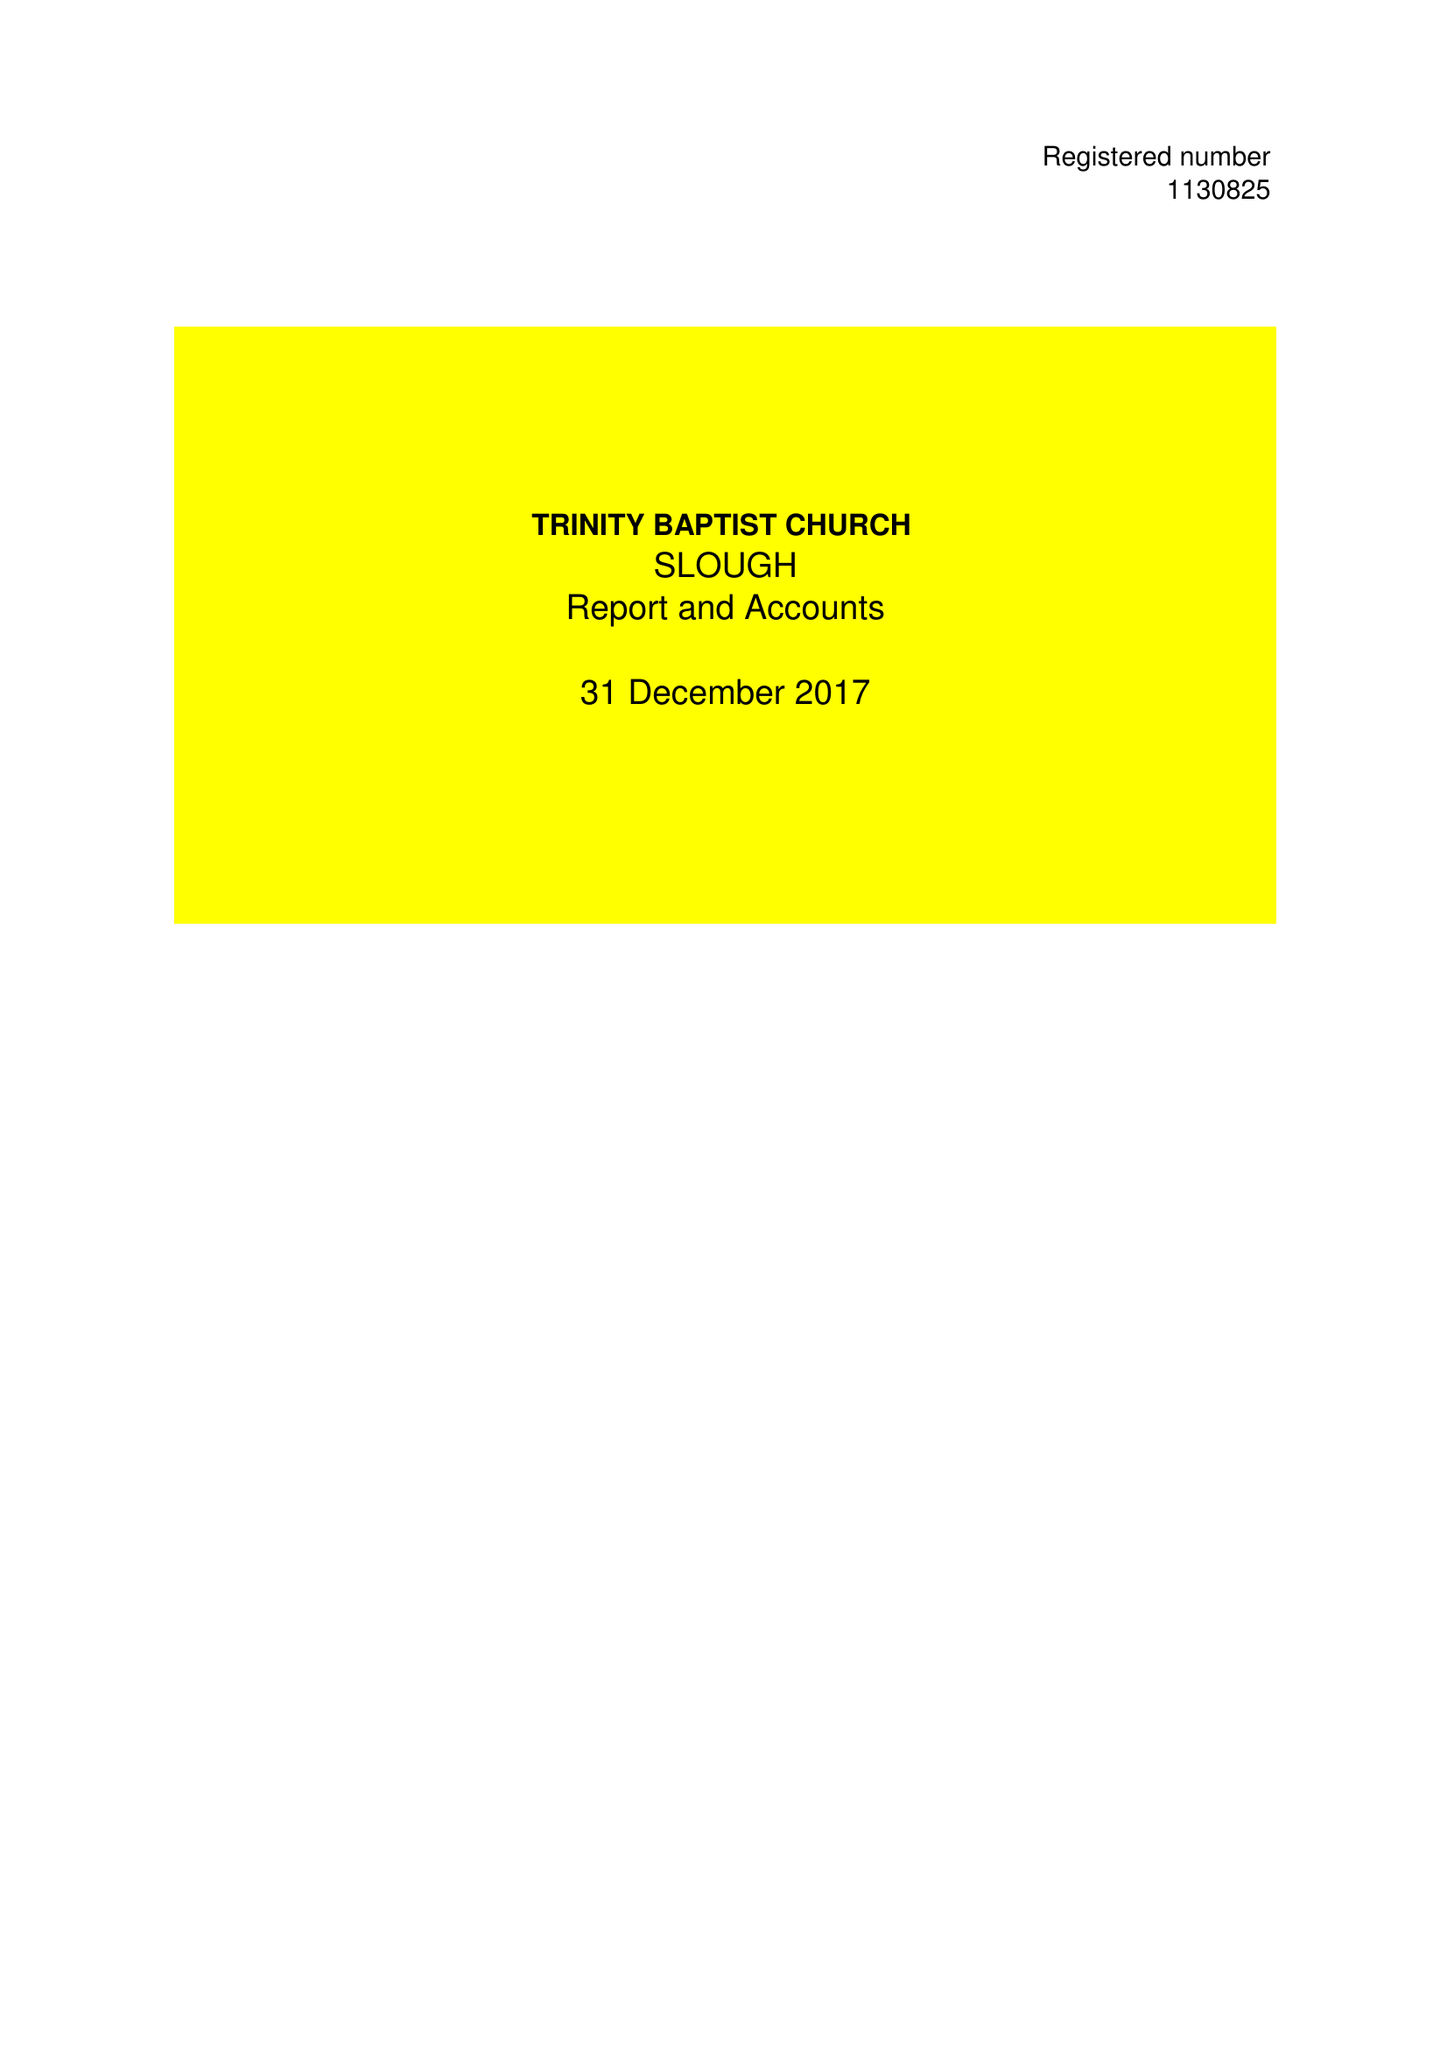What is the value for the spending_annually_in_british_pounds?
Answer the question using a single word or phrase. 49163.00 